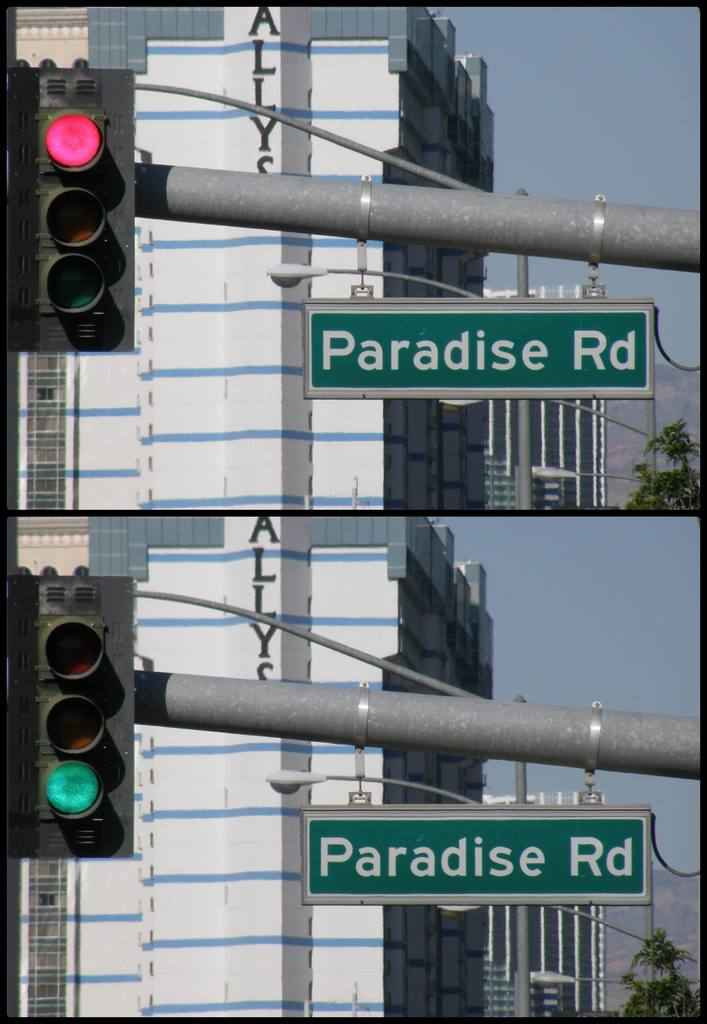What does the red traffic light indicate in this context? The red traffic light indicates that vehicles along this road are required to stop. This ensures safety at intersections, allowing for controlled movement of traffic across different directions. 